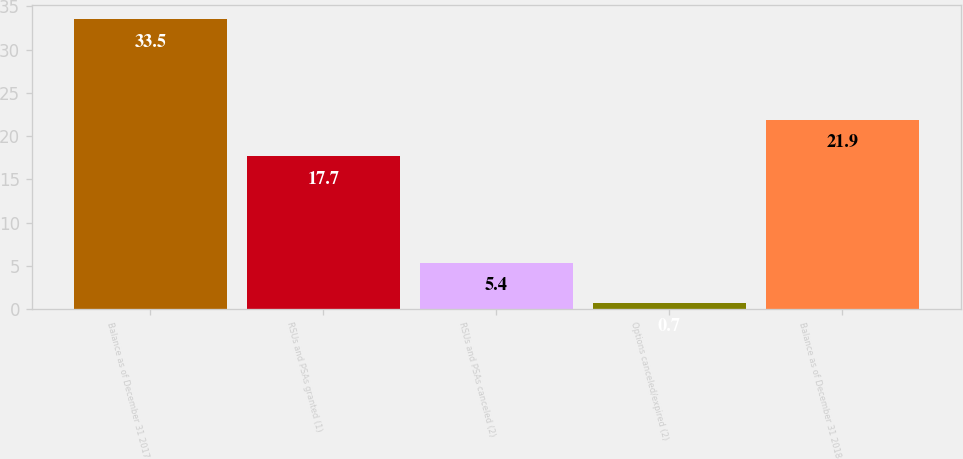Convert chart to OTSL. <chart><loc_0><loc_0><loc_500><loc_500><bar_chart><fcel>Balance as of December 31 2017<fcel>RSUs and PSAs granted (1)<fcel>RSUs and PSAs canceled (2)<fcel>Options canceled/expired (2)<fcel>Balance as of December 31 2018<nl><fcel>33.5<fcel>17.7<fcel>5.4<fcel>0.7<fcel>21.9<nl></chart> 